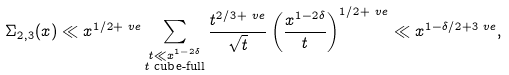Convert formula to latex. <formula><loc_0><loc_0><loc_500><loc_500>\Sigma _ { 2 , 3 } ( x ) & \ll x ^ { 1 / 2 + \ v e } \sum _ { \substack { t \ll x ^ { 1 - 2 \delta } \\ \text {$t$ cube-full} } } \frac { t ^ { 2 / 3 + \ v e } } { \sqrt { t } } \left ( \frac { x ^ { 1 - 2 \delta } } { t } \right ) ^ { 1 / 2 + \ v e } \ll x ^ { 1 - \delta / 2 + 3 \ v e } ,</formula> 